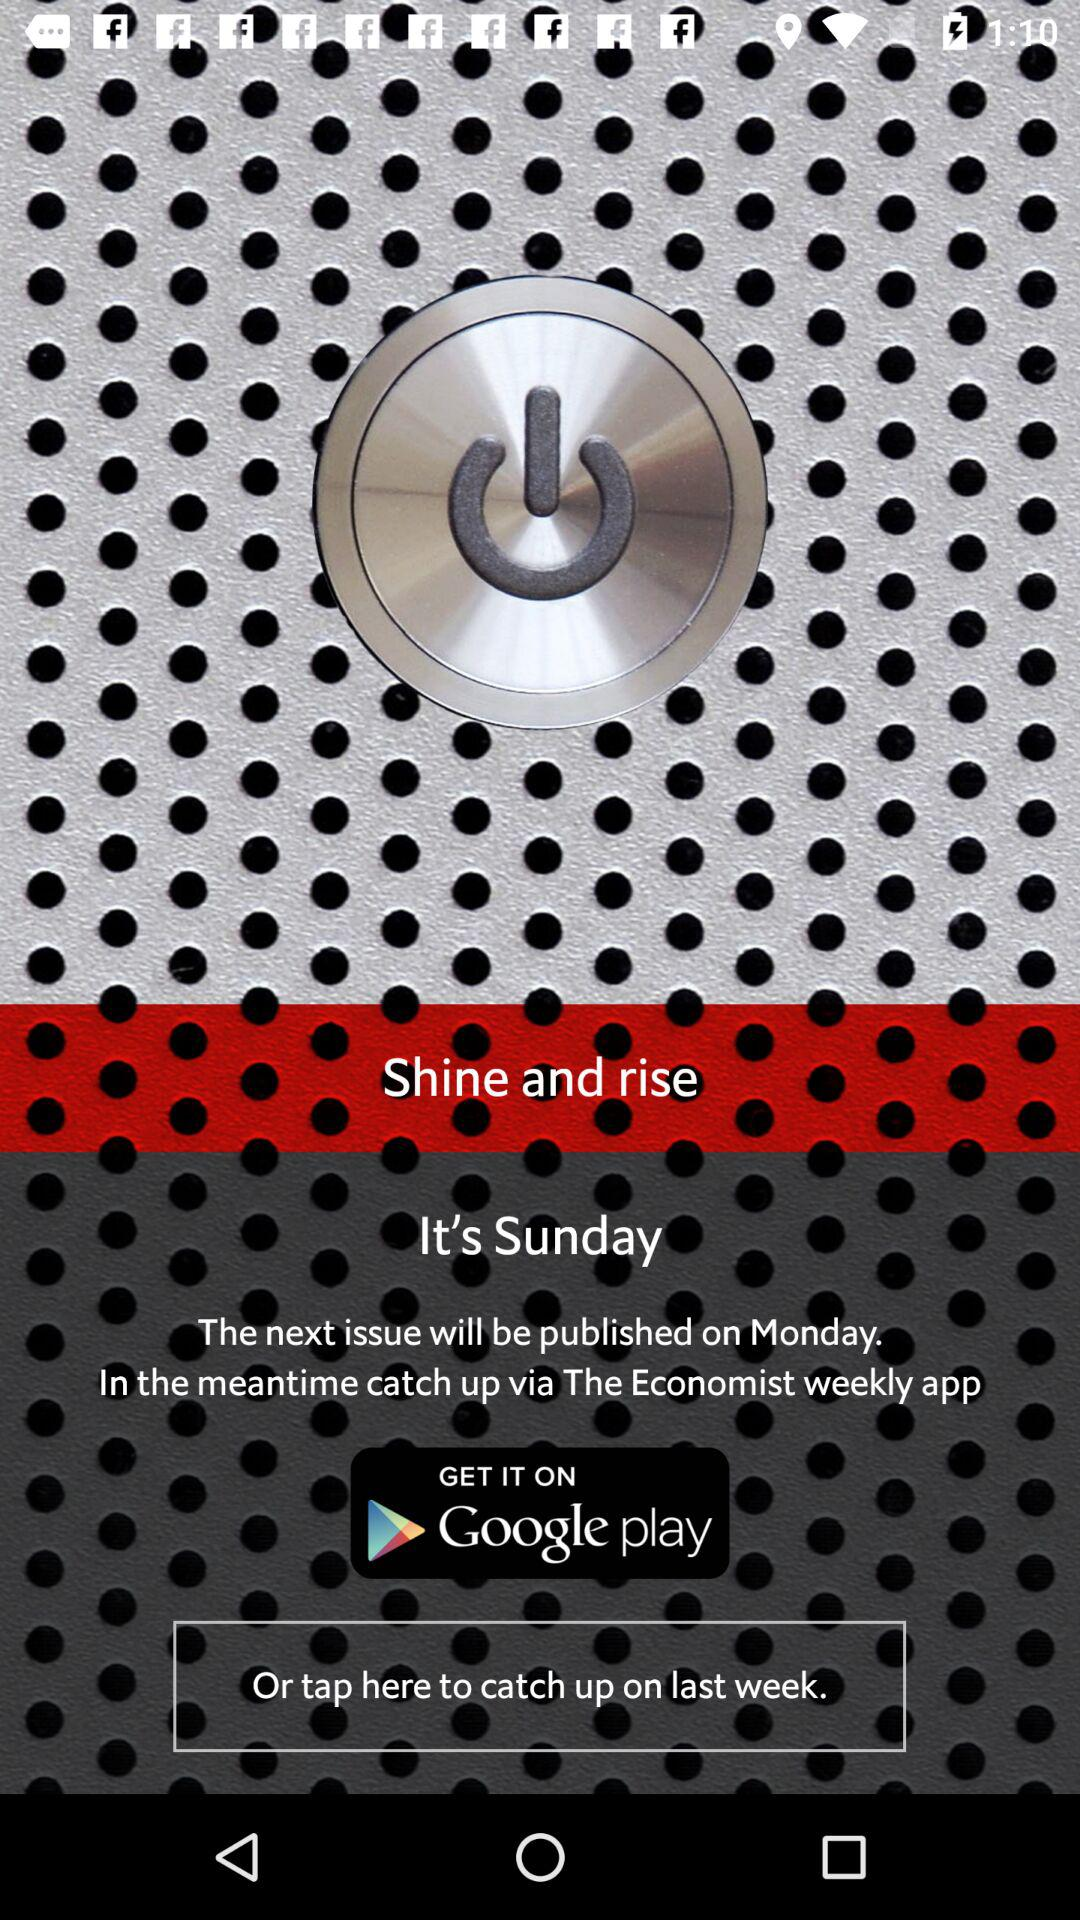From where can the application be downloaded? The application can be downloaded from "Google play". 